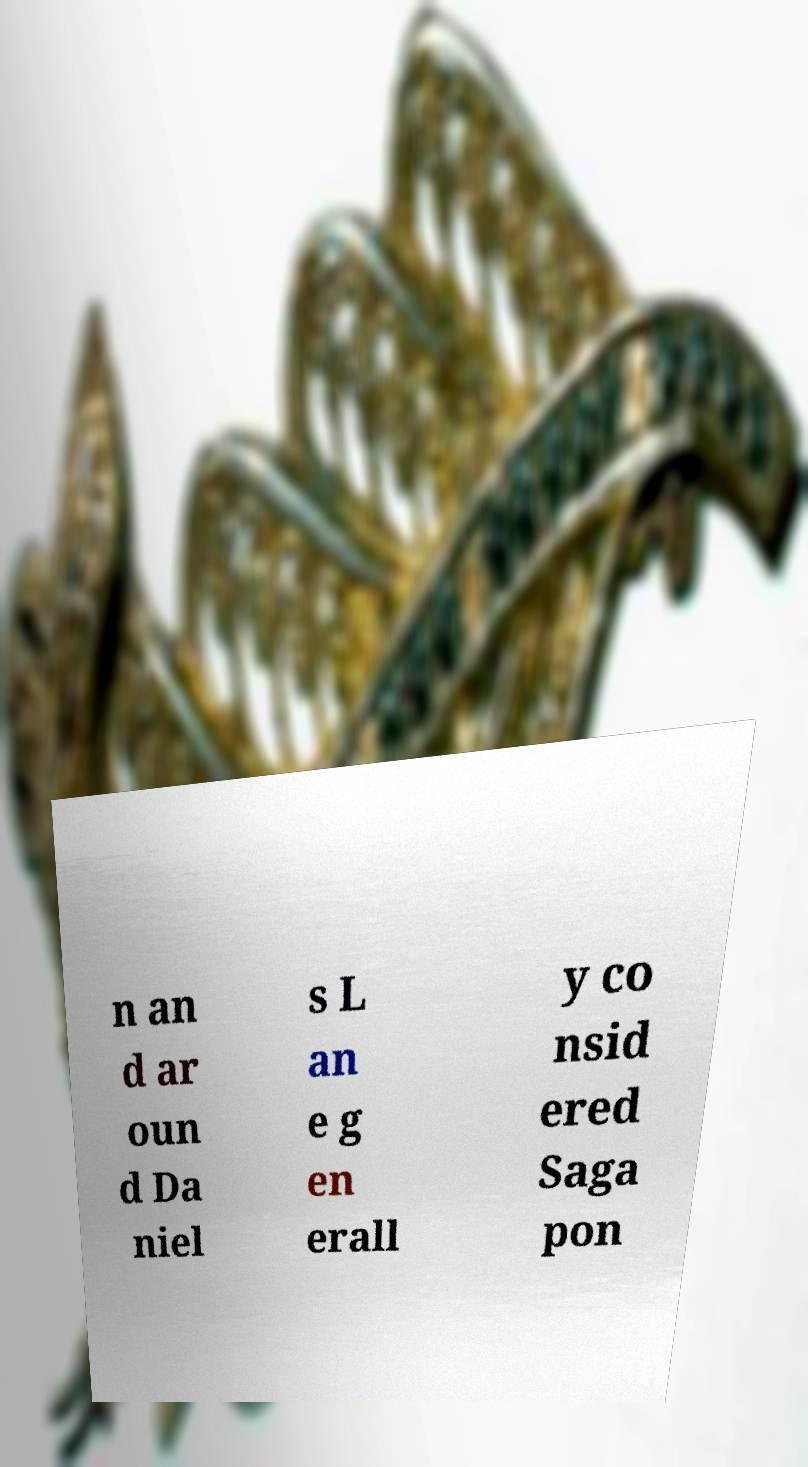For documentation purposes, I need the text within this image transcribed. Could you provide that? n an d ar oun d Da niel s L an e g en erall y co nsid ered Saga pon 